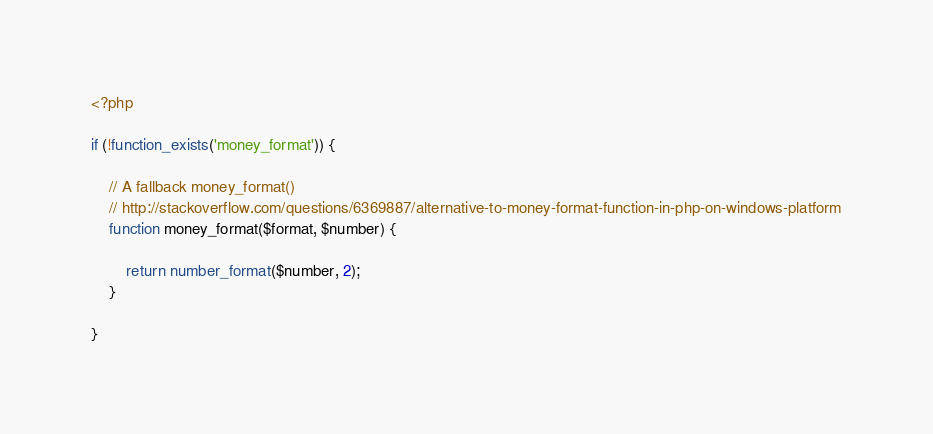Convert code to text. <code><loc_0><loc_0><loc_500><loc_500><_PHP_><?php

if (!function_exists('money_format')) {

    // A fallback money_format()
    // http://stackoverflow.com/questions/6369887/alternative-to-money-format-function-in-php-on-windows-platform
    function money_format($format, $number) {

        return number_format($number, 2);
    }

}
</code> 